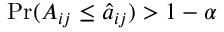Convert formula to latex. <formula><loc_0><loc_0><loc_500><loc_500>P r ( A _ { i j } \leq \hat { a } _ { i j } ) > 1 - \alpha</formula> 